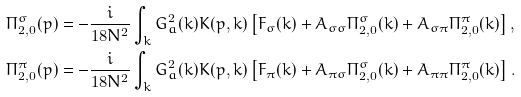Convert formula to latex. <formula><loc_0><loc_0><loc_500><loc_500>\Pi _ { 2 , 0 } ^ { \sigma } ( p ) & = - \frac { i } { 1 8 N ^ { 2 } } \int _ { k } G _ { a } ^ { 2 } ( k ) K ( p , k ) \left [ F _ { \sigma } ( k ) + A _ { \sigma \sigma } \Pi _ { 2 , 0 } ^ { \sigma } ( k ) + A _ { \sigma \pi } \Pi _ { 2 , 0 } ^ { \pi } ( k ) \right ] , \\ \Pi _ { 2 , 0 } ^ { \pi } ( p ) & = - \frac { i } { 1 8 N ^ { 2 } } \int _ { k } G _ { a } ^ { 2 } ( k ) K ( p , k ) \left [ F _ { \pi } ( k ) + A _ { \pi \sigma } \Pi _ { 2 , 0 } ^ { \sigma } ( k ) + A _ { \pi \pi } \Pi _ { 2 , 0 } ^ { \pi } ( k ) \right ] .</formula> 